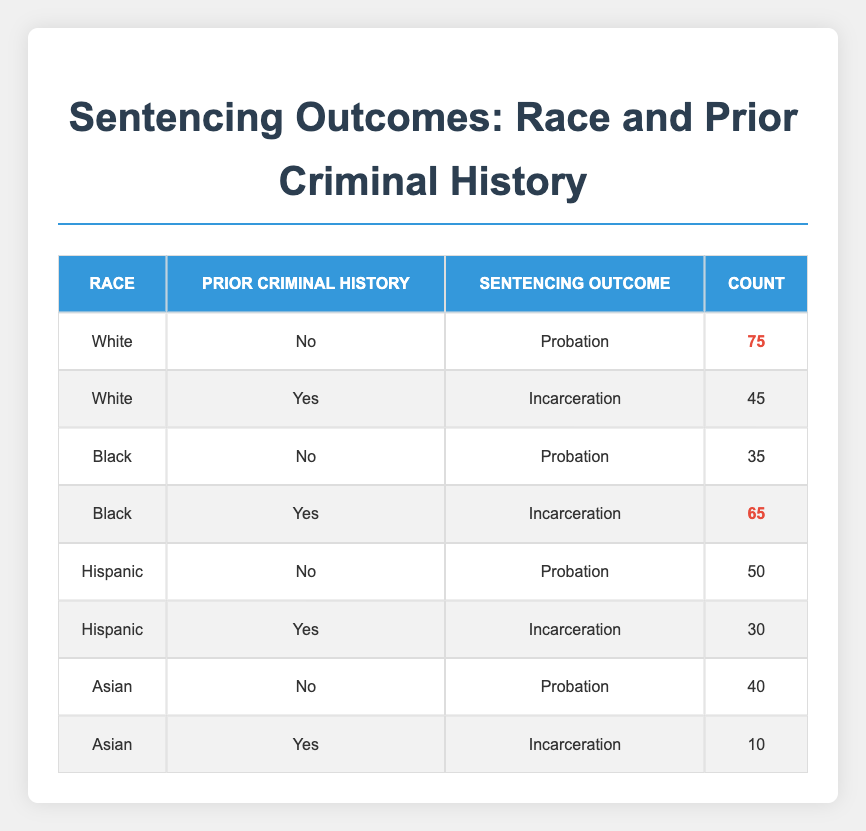What is the total number of offenders sentenced to probation across all races? To find the total number of offenders sentenced to probation, I need to check the counts for "Probation" in each race: White (75), Black (35), Hispanic (50), and Asian (40). Adding these values gives 75 + 35 + 50 + 40 = 200.
Answer: 200 How many Black offenders with prior criminal history were incarcerated? The count for Black offenders with prior criminal history (Yes) is directly provided in the table as 65.
Answer: 65 Is it true that all Asian offenders without prior criminal history received probation? In the table, the only Asian offender without prior criminal history is listed as receiving probation. Therefore, the fact is true.
Answer: Yes What is the difference in the number of incarcerations between White and Hispanic offenders with prior criminal history? The count for White offenders with prior criminal history (Yes) is 45, while for Hispanic offenders it is 30. The difference is 45 - 30 = 15.
Answer: 15 How many offenders of each race were incarcerated, and which race had the highest number? The counts for incarcerated offenders are: White (45), Black (65), Hispanic (30), and Asian (10). The highest count is for Black offenders (65).
Answer: Black What percentage of offenders with no prior criminal history were sentenced to probation? The total number of offenders with no prior criminal history is calculated by summing: White (75), Black (35), Hispanic (50), and Asian (40) which totals 200. Since all of these offenders received probation, the percentage is (200/200) * 100 = 100%.
Answer: 100% Which race had the lowest count of offenders sentenced to incarceration? Referring to the incarceration counts: White (45), Black (65), Hispanic (30), and Asian (10). The lowest count is for Asian offenders (10).
Answer: Asian What is the total number of offenders categorized as Hispanic? To find the total for Hispanic offenders, I sum both categories: Probation (50) and Incarceration (30), resulting in a total count of 50 + 30 = 80.
Answer: 80 Is it correct that fewer Hispanic offenders were incarcerated compared to Asian offenders? The table shows Hispanic offenders incarcerated (30) versus Asian offenders (10); therefore, the statement is incorrect as Hispanic offenders were more.
Answer: No 